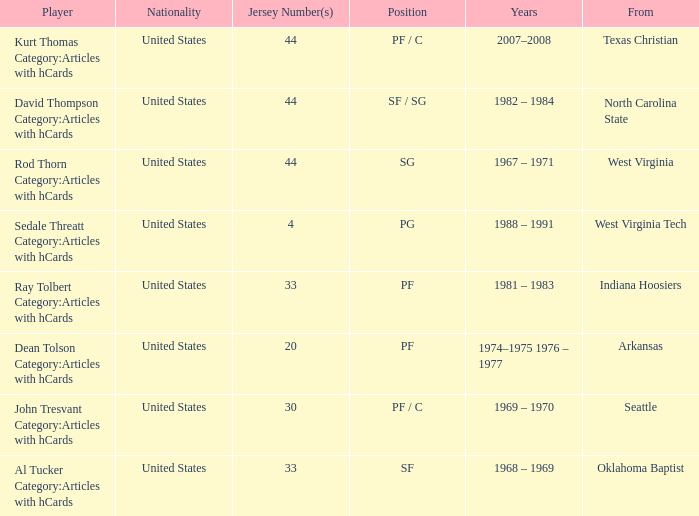What years did the player with the jersey number bigger than 20 play? 2007–2008, 1982 – 1984, 1967 – 1971, 1981 – 1983, 1969 – 1970, 1968 – 1969. Give me the full table as a dictionary. {'header': ['Player', 'Nationality', 'Jersey Number(s)', 'Position', 'Years', 'From'], 'rows': [['Kurt Thomas Category:Articles with hCards', 'United States', '44', 'PF / C', '2007–2008', 'Texas Christian'], ['David Thompson Category:Articles with hCards', 'United States', '44', 'SF / SG', '1982 – 1984', 'North Carolina State'], ['Rod Thorn Category:Articles with hCards', 'United States', '44', 'SG', '1967 – 1971', 'West Virginia'], ['Sedale Threatt Category:Articles with hCards', 'United States', '4', 'PG', '1988 – 1991', 'West Virginia Tech'], ['Ray Tolbert Category:Articles with hCards', 'United States', '33', 'PF', '1981 – 1983', 'Indiana Hoosiers'], ['Dean Tolson Category:Articles with hCards', 'United States', '20', 'PF', '1974–1975 1976 – 1977', 'Arkansas'], ['John Tresvant Category:Articles with hCards', 'United States', '30', 'PF / C', '1969 – 1970', 'Seattle'], ['Al Tucker Category:Articles with hCards', 'United States', '33', 'SF', '1968 – 1969', 'Oklahoma Baptist']]} 